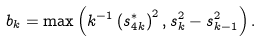Convert formula to latex. <formula><loc_0><loc_0><loc_500><loc_500>b _ { k } = \max \left ( k ^ { - 1 } \left ( s _ { 4 k } ^ { \ast } \right ) ^ { 2 } , s _ { k } ^ { 2 } - s _ { k - 1 } ^ { 2 } \right ) .</formula> 